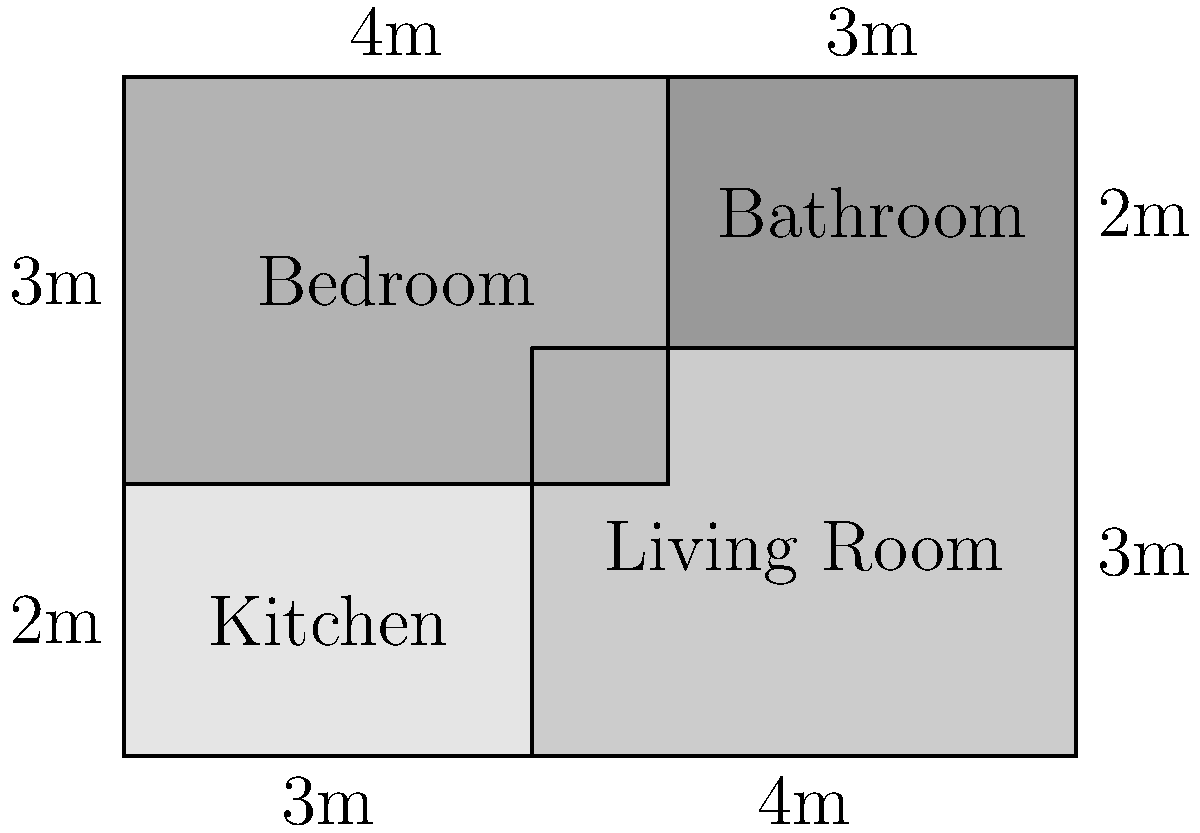In the quirky world of sitcom apartments, you've been tasked with calculating the perimeter of this unconventional floor plan. The apartment consists of a kitchen, living room, bedroom, and bathroom, each with its own unique shape. Given the dimensions shown in the floor plan, what is the total perimeter of the apartment in meters? Don't forget to channel your inner Anne Beatts and find the humor in measuring the boundaries of fictional living spaces! Let's break this down step-by-step, imagining we're writing a comedic sketch about an overzealous architect:

1) First, let's identify the outer edges of the apartment:
   - Left side: $2m + 3m = 5m$
   - Right side: $3m + 2m = 5m$
   - Bottom: $3m + 4m = 7m$
   - Top: $4m + 3m = 7m$

2) Now, let's add these up with a touch of humor:
   $5m + 5m + 7m + 7m = 24m$

3) But wait! We're not done yet. Remember the awkward jutting-out part between the kitchen and bedroom? That's like the apartment's own little comedy sidekick. We need to account for it:
   - Additional vertical line: $1m$
   - Additional horizontal line: $1m$

4) Adding these to our total:
   $24m + 1m + 1m = 26m$

5) And there you have it! The perimeter of our sitcom apartment, where the walls are probably filled with canned laughter instead of insulation.
Answer: $26m$ 